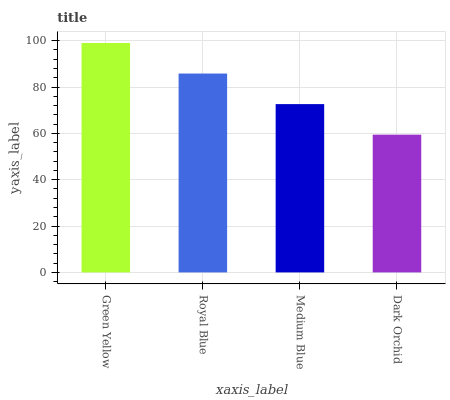Is Royal Blue the minimum?
Answer yes or no. No. Is Royal Blue the maximum?
Answer yes or no. No. Is Green Yellow greater than Royal Blue?
Answer yes or no. Yes. Is Royal Blue less than Green Yellow?
Answer yes or no. Yes. Is Royal Blue greater than Green Yellow?
Answer yes or no. No. Is Green Yellow less than Royal Blue?
Answer yes or no. No. Is Royal Blue the high median?
Answer yes or no. Yes. Is Medium Blue the low median?
Answer yes or no. Yes. Is Medium Blue the high median?
Answer yes or no. No. Is Dark Orchid the low median?
Answer yes or no. No. 